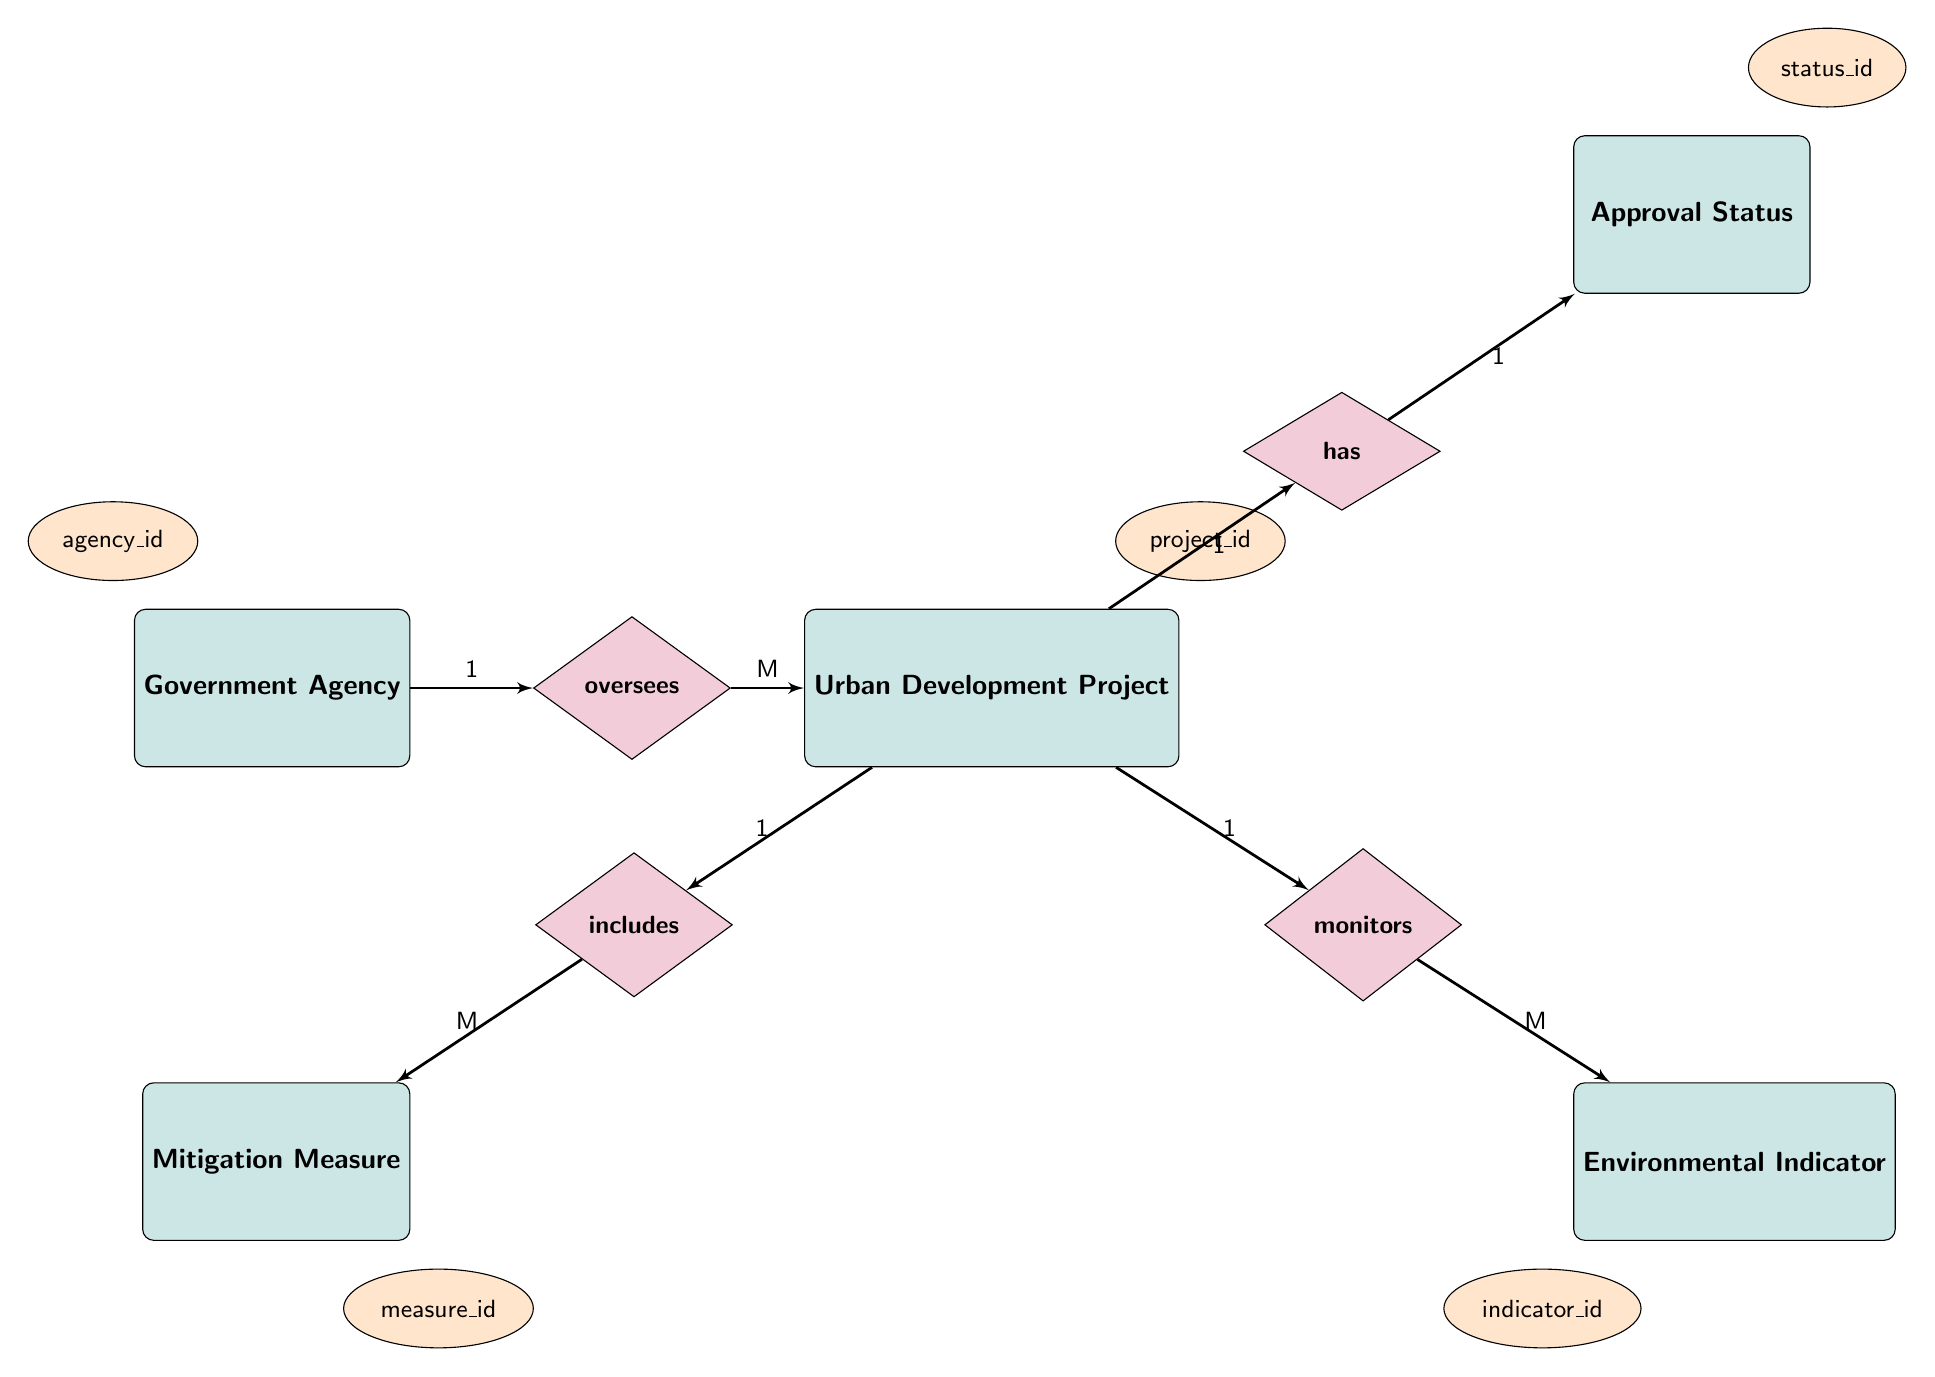What entity oversees Urban Development Projects? The diagram shows a relationship between Government Agency and Urban Development Project, labeled as "oversees". Therefore, "Government Agency" is responsible for overseeing "Urban Development Projects".
Answer: Government Agency How many relationships are present in the diagram? There are four relationships shown in the diagram: oversees, monitors, includes, and has, connecting various entities. Hence, the count of relationships is four.
Answer: 4 What is the cardinality between Urban Development Project and Environmental Indicator? The diagram indicates the relationship "monitors" between Urban Development Project and Environmental Indicator, with cardinality labeled as "1:M". This indicates one Urban Development Project can monitor multiple Environmental Indicators.
Answer: 1:M What relationship does Urban Development Project have with Approval Status? The diagram indicates a direct relationship labeled "has" between Urban Development Project and Approval Status, which implies Urban Development Project possesses an Approval Status.
Answer: has How many Environmental Indicators can an Urban Development Project monitor? The diagram specifies a one-to-many relationship (1:M) between Urban Development Project and Environmental Indicator, meaning one Urban Development Project can monitor many Environmental Indicators.
Answer: Many Which entity includes Mitigation Measures? According to the diagram, the relationship labeled "includes" indicates that Urban Development Project encompasses various Mitigation Measures. Thus, the entity that includes Mitigation Measures is Urban Development Project.
Answer: Urban Development Project What type of diagram is being represented? The structure depicted in the diagram clearly follows the conventions of an Entity Relationship Diagram, which is used to demonstrate the relationships between different entities.
Answer: Entity Relationship Diagram What is an example of an attribute for Government Agency? The diagram features the attribute "agency_id" associated with the Government Agency entity, serving as a unique identifier for the agency.
Answer: agency_id 